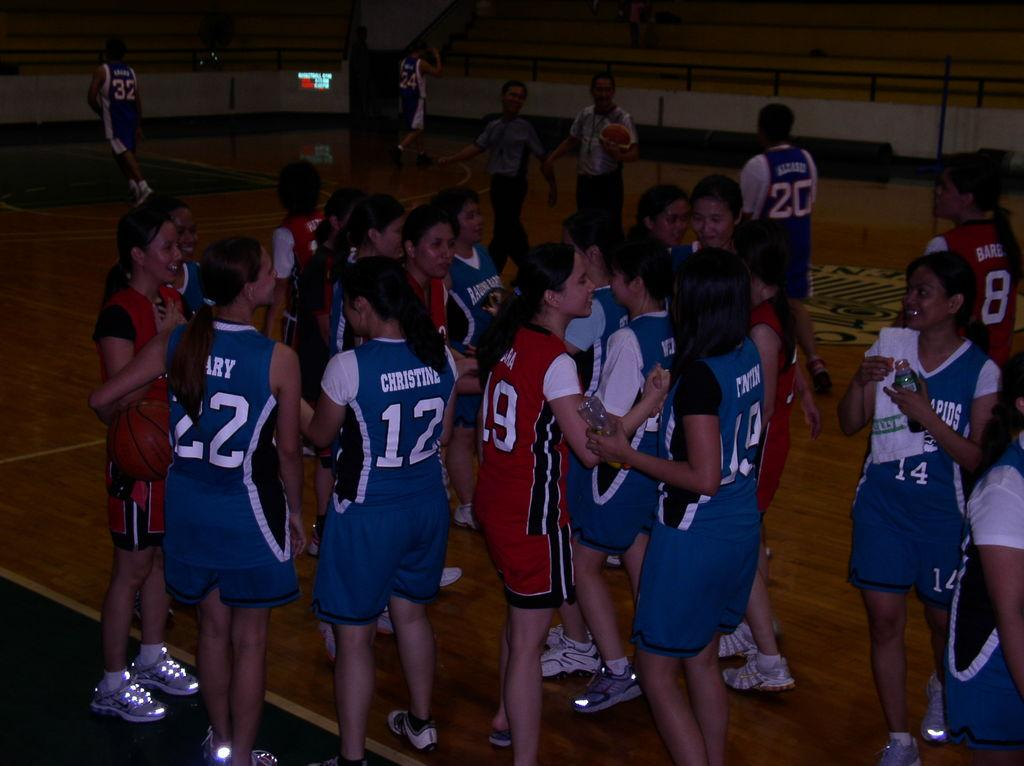<image>
Share a concise interpretation of the image provided. A player with the number 12 on stands with other players. 